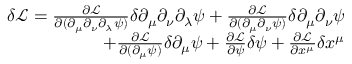Convert formula to latex. <formula><loc_0><loc_0><loc_500><loc_500>\begin{array} { r } { \delta \mathcal { L } = \frac { \partial \mathcal { L } } { \partial ( \partial _ { \mu } \partial _ { \nu } \partial _ { \lambda } \psi ) } \delta \partial _ { \mu } \partial _ { \nu } \partial _ { \lambda } \psi + \frac { \partial \mathcal { L } } { \partial ( \partial _ { \mu } \partial _ { \nu } \psi ) } \delta \partial _ { \mu } \partial _ { \nu } \psi } \\ { + \frac { \partial \mathcal { L } } { \partial ( \partial _ { \mu } \psi ) } \delta \partial _ { \mu } \psi + \frac { \partial \mathcal { L } } { \partial \psi } \delta \psi + \frac { \partial \mathcal { L } } { \partial x ^ { \mu } } \delta x ^ { \mu } } \end{array}</formula> 